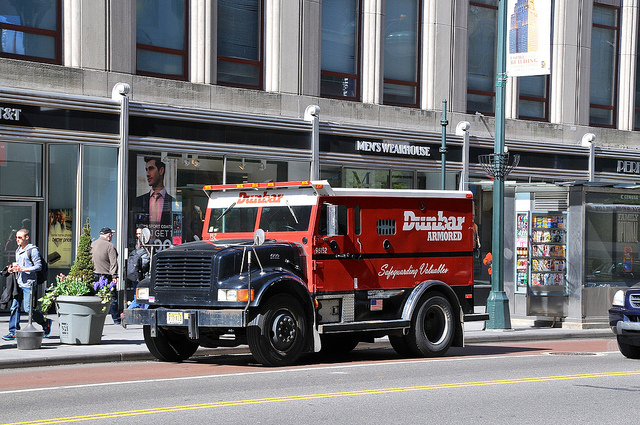<image>What is flying on a pole over the building? It is unknown what is flying on a pole over the building. It can be a flag, banner, or nothing. What is flying on a pole over the building? I am not sure what is flying on a pole over the building. It can be seen as a flag, banner, or nothing. 